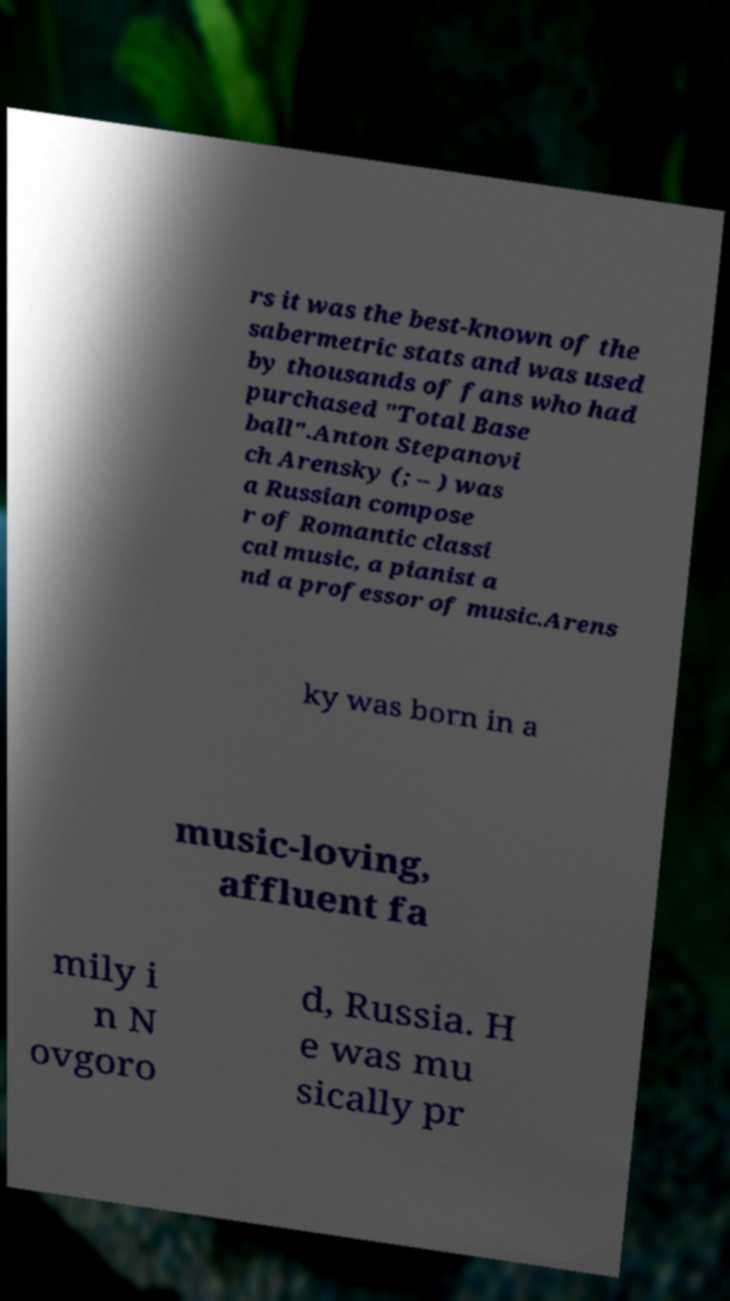Could you assist in decoding the text presented in this image and type it out clearly? rs it was the best-known of the sabermetric stats and was used by thousands of fans who had purchased "Total Base ball".Anton Stepanovi ch Arensky (; – ) was a Russian compose r of Romantic classi cal music, a pianist a nd a professor of music.Arens ky was born in a music-loving, affluent fa mily i n N ovgoro d, Russia. H e was mu sically pr 